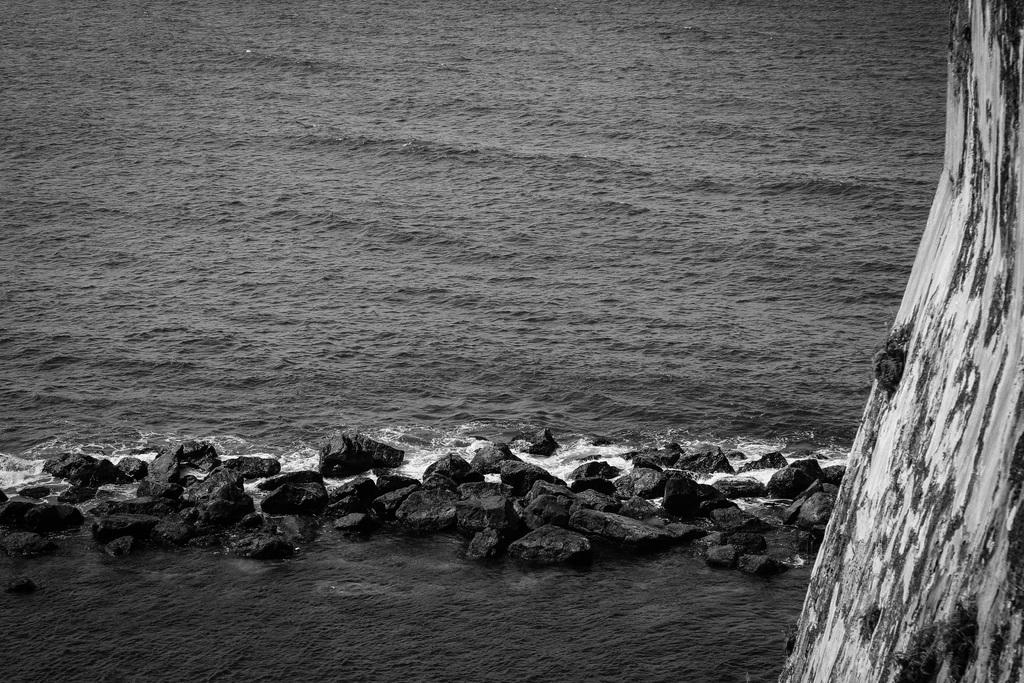What is the primary element visible in the image? There is water in the image. What objects can be seen in the water? There are stones arranged in sequence in the water. What other object is present in the image? There is a tree branch in the image. What type of lunch is being served on the tree branch in the image? There is no lunch or any food item present on the tree branch in the image. 